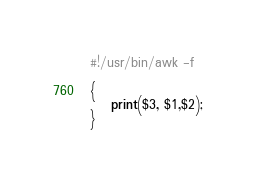Convert code to text. <code><loc_0><loc_0><loc_500><loc_500><_Awk_>#!/usr/bin/awk -f

{
    print($3, $1,$2);
}
</code> 